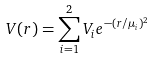Convert formula to latex. <formula><loc_0><loc_0><loc_500><loc_500>V ( r ) = \sum ^ { 2 } _ { i = 1 } V _ { i } e ^ { - ( r / \mu _ { i } ) ^ { 2 } }</formula> 